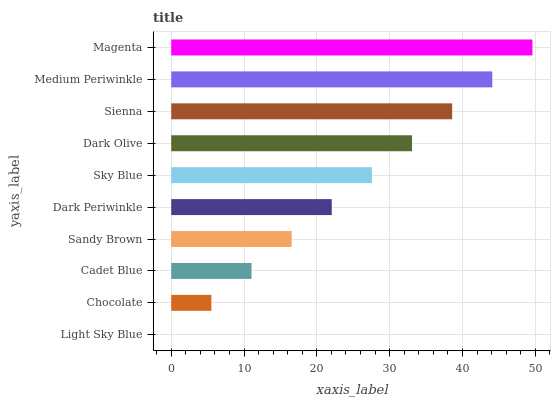Is Light Sky Blue the minimum?
Answer yes or no. Yes. Is Magenta the maximum?
Answer yes or no. Yes. Is Chocolate the minimum?
Answer yes or no. No. Is Chocolate the maximum?
Answer yes or no. No. Is Chocolate greater than Light Sky Blue?
Answer yes or no. Yes. Is Light Sky Blue less than Chocolate?
Answer yes or no. Yes. Is Light Sky Blue greater than Chocolate?
Answer yes or no. No. Is Chocolate less than Light Sky Blue?
Answer yes or no. No. Is Sky Blue the high median?
Answer yes or no. Yes. Is Dark Periwinkle the low median?
Answer yes or no. Yes. Is Medium Periwinkle the high median?
Answer yes or no. No. Is Sky Blue the low median?
Answer yes or no. No. 